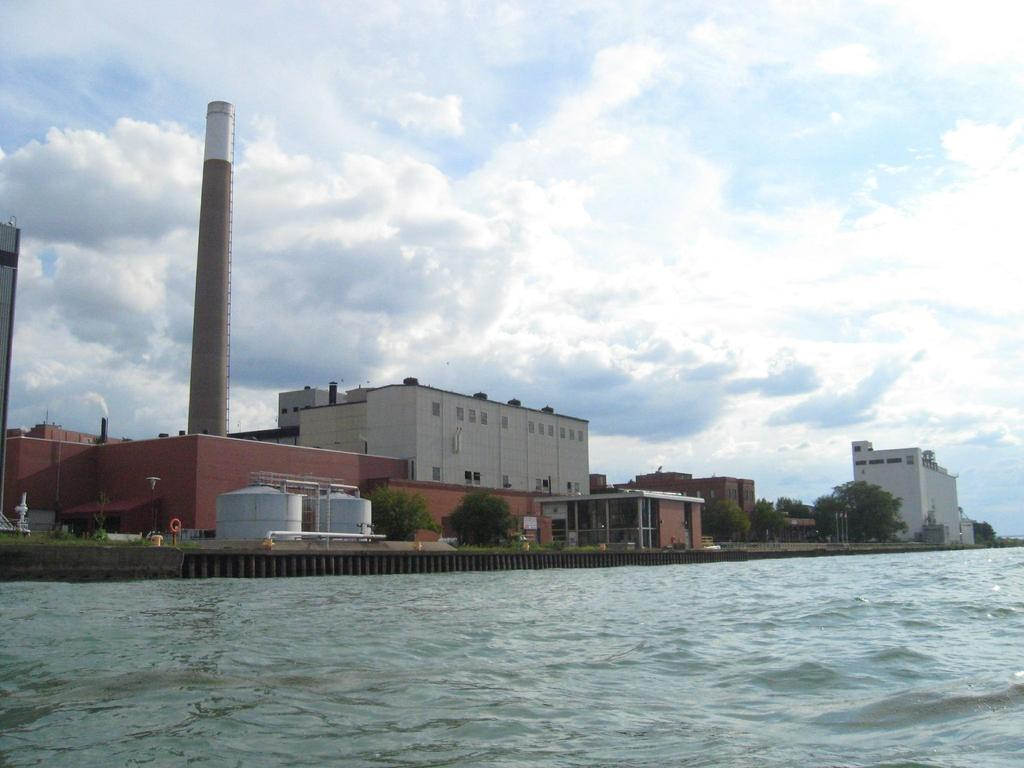What is located in the foreground of the image? There is a water body in the foreground of the image. What can be seen in the middle of the image? There are buildings, trees, and a factory in the middle of the image. What is visible at the top of the image? The sky is visible at the top of the image. Can you tell me how many worms are crawling on the seashore in the image? There is no seashore or worms present in the image. What is the interest rate of the factory in the image? The image does not provide information about the factory's interest rate. 